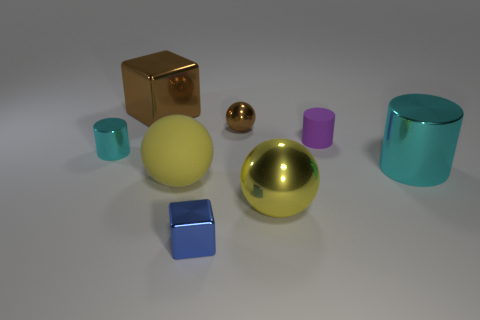Add 1 tiny blue cubes. How many objects exist? 9 Subtract all cubes. How many objects are left? 6 Subtract 1 purple cylinders. How many objects are left? 7 Subtract all small purple objects. Subtract all blue cubes. How many objects are left? 6 Add 5 big blocks. How many big blocks are left? 6 Add 6 big green objects. How many big green objects exist? 6 